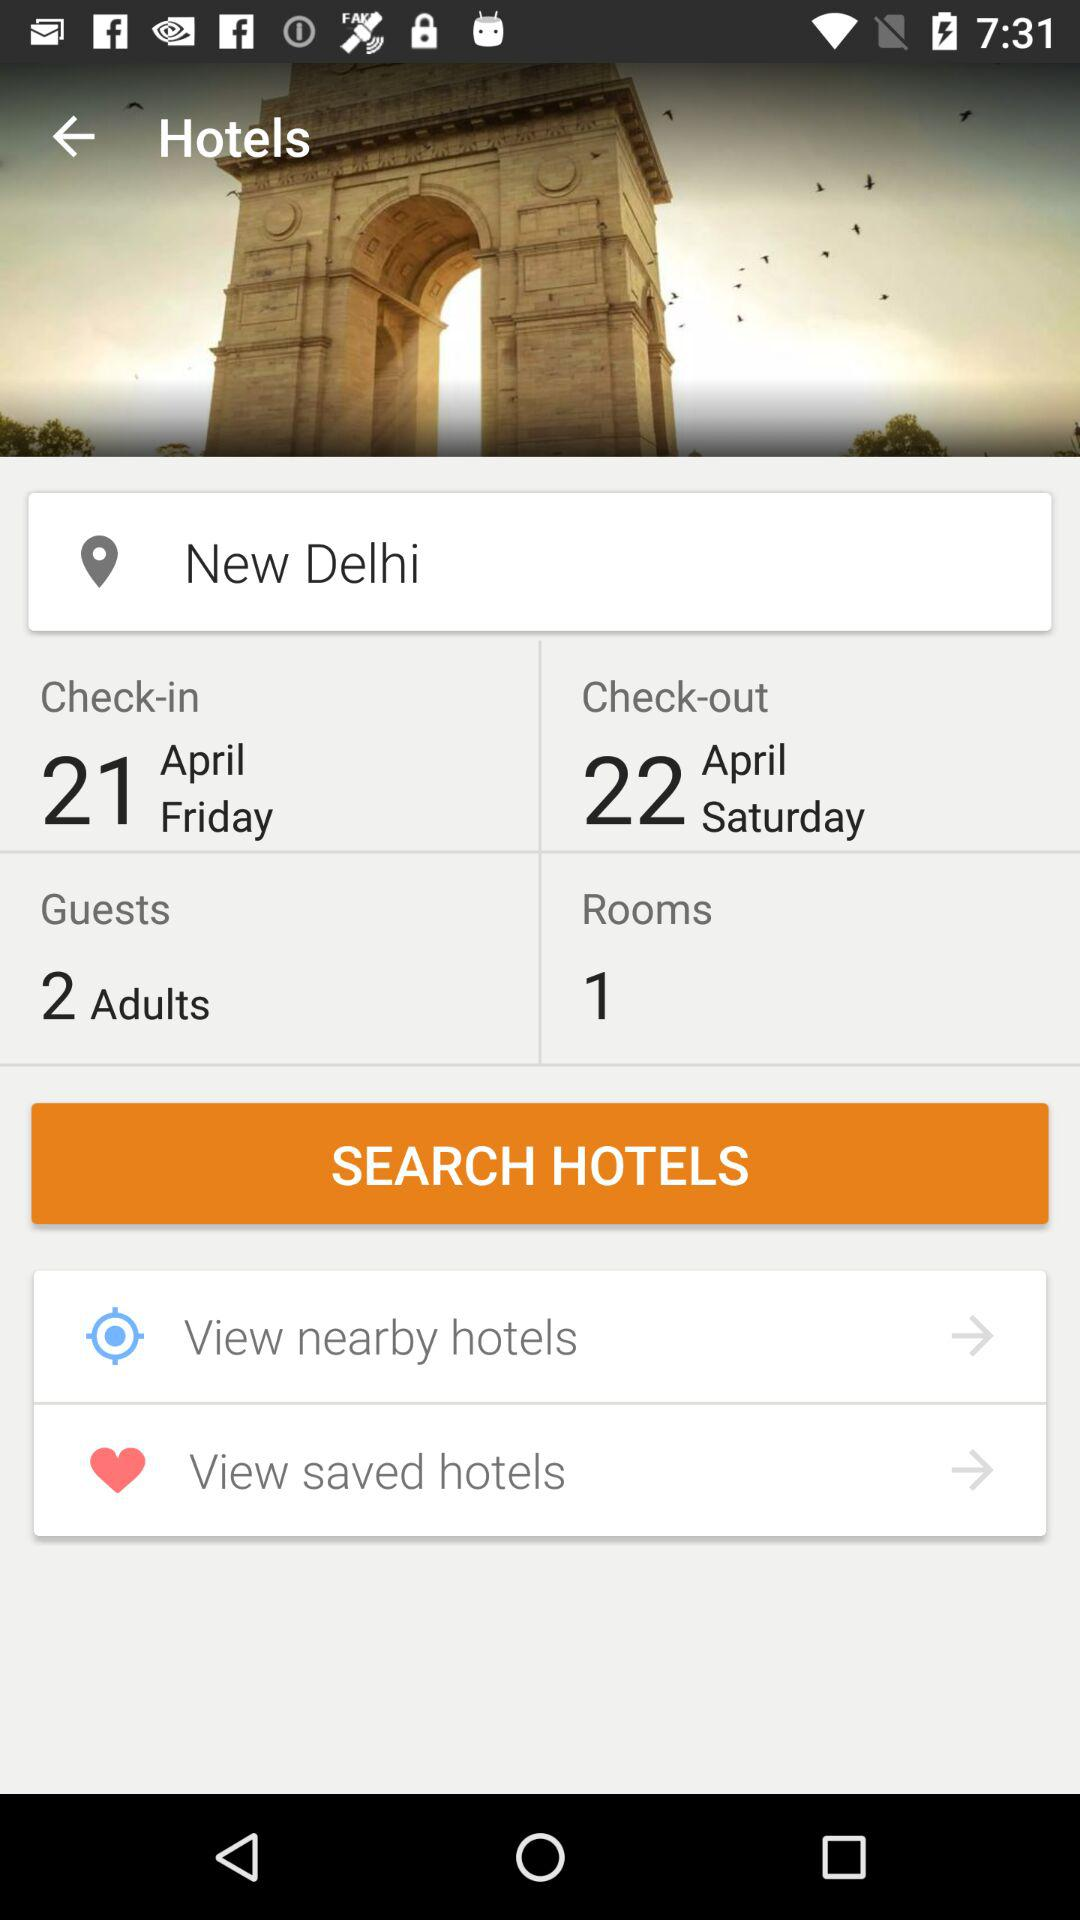What is the location? The location is New Delhi. 